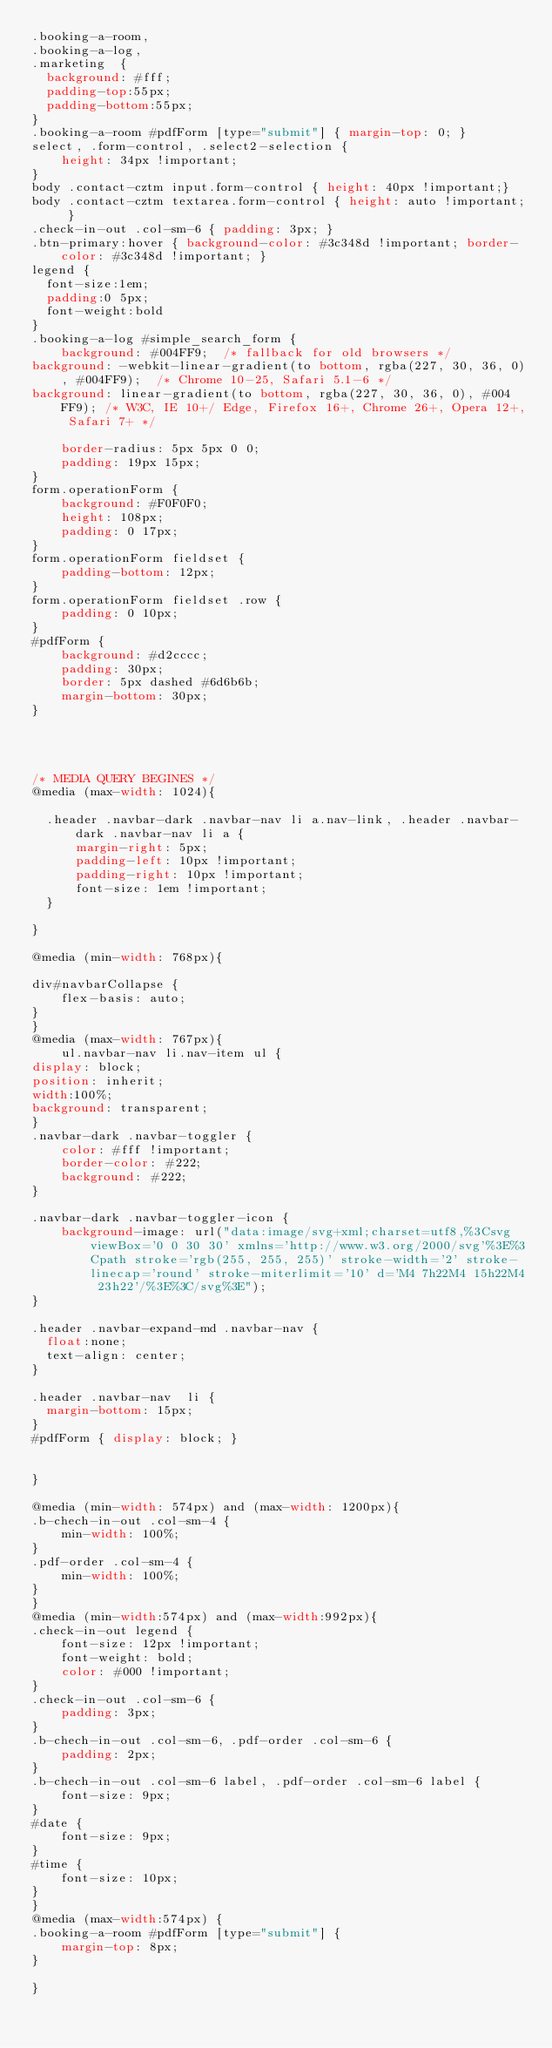Convert code to text. <code><loc_0><loc_0><loc_500><loc_500><_CSS_>.booking-a-room,
.booking-a-log,
.marketing  {
  background: #fff;
  padding-top:55px;
  padding-bottom:55px;
}
.booking-a-room #pdfForm [type="submit"] { margin-top: 0; }
select, .form-control, .select2-selection {
    height: 34px !important;
}
body .contact-cztm input.form-control { height: 40px !important;}
body .contact-cztm textarea.form-control { height: auto !important; }
.check-in-out .col-sm-6 { padding: 3px; }
.btn-primary:hover { background-color: #3c348d !important; border-color: #3c348d !important; }
legend {
  font-size:1em;
  padding:0 5px;
  font-weight:bold
}
.booking-a-log #simple_search_form {
    background: #004FF9;  /* fallback for old browsers */
background: -webkit-linear-gradient(to bottom, rgba(227, 30, 36, 0), #004FF9);  /* Chrome 10-25, Safari 5.1-6 */
background: linear-gradient(to bottom, rgba(227, 30, 36, 0), #004FF9); /* W3C, IE 10+/ Edge, Firefox 16+, Chrome 26+, Opera 12+, Safari 7+ */

    border-radius: 5px 5px 0 0;
    padding: 19px 15px;
}
form.operationForm {
    background: #F0F0F0;
    height: 108px;
    padding: 0 17px;
}
form.operationForm fieldset {
    padding-bottom: 12px;
}
form.operationForm fieldset .row {
    padding: 0 10px;
}
#pdfForm {
    background: #d2cccc;
    padding: 30px;
    border: 5px dashed #6d6b6b;
    margin-bottom: 30px;
}




/* MEDIA QUERY BEGINES */
@media (max-width: 1024){

	.header .navbar-dark .navbar-nav li a.nav-link, .header .navbar-dark .navbar-nav li a {
	    margin-right: 5px;
	    padding-left: 10px !important;
	    padding-right: 10px !important;
	    font-size: 1em !important;
	}

}

@media (min-width: 768px){

div#navbarCollapse {
    flex-basis: auto;
}
}
@media (max-width: 767px){
    ul.navbar-nav li.nav-item ul {
display: block;
position: inherit;
width:100%;
background: transparent;
}
.navbar-dark .navbar-toggler {
    color: #fff !important;
    border-color: #222;
    background: #222;
}

.navbar-dark .navbar-toggler-icon {
    background-image: url("data:image/svg+xml;charset=utf8,%3Csvg viewBox='0 0 30 30' xmlns='http://www.w3.org/2000/svg'%3E%3Cpath stroke='rgb(255, 255, 255)' stroke-width='2' stroke-linecap='round' stroke-miterlimit='10' d='M4 7h22M4 15h22M4 23h22'/%3E%3C/svg%3E");
}

.header .navbar-expand-md .navbar-nav { 
	float:none;
	text-align: center;
}

.header .navbar-nav  li {
	margin-bottom: 15px;
}
#pdfForm { display: block; }


}

@media (min-width: 574px) and (max-width: 1200px){ 
.b-chech-in-out .col-sm-4 {
    min-width: 100%;
}
.pdf-order .col-sm-4 {
    min-width: 100%;
}
}
@media (min-width:574px) and (max-width:992px){
.check-in-out legend {
    font-size: 12px !important;
    font-weight: bold;
    color: #000 !important;
}
.check-in-out .col-sm-6 {
    padding: 3px;
}
.b-chech-in-out .col-sm-6, .pdf-order .col-sm-6 {
    padding: 2px;
}
.b-chech-in-out .col-sm-6 label, .pdf-order .col-sm-6 label {
    font-size: 9px;
}
#date {
    font-size: 9px;
}
#time {
    font-size: 10px;
}
}
@media (max-width:574px) {  
.booking-a-room #pdfForm [type="submit"] {
    margin-top: 8px;
}

}</code> 